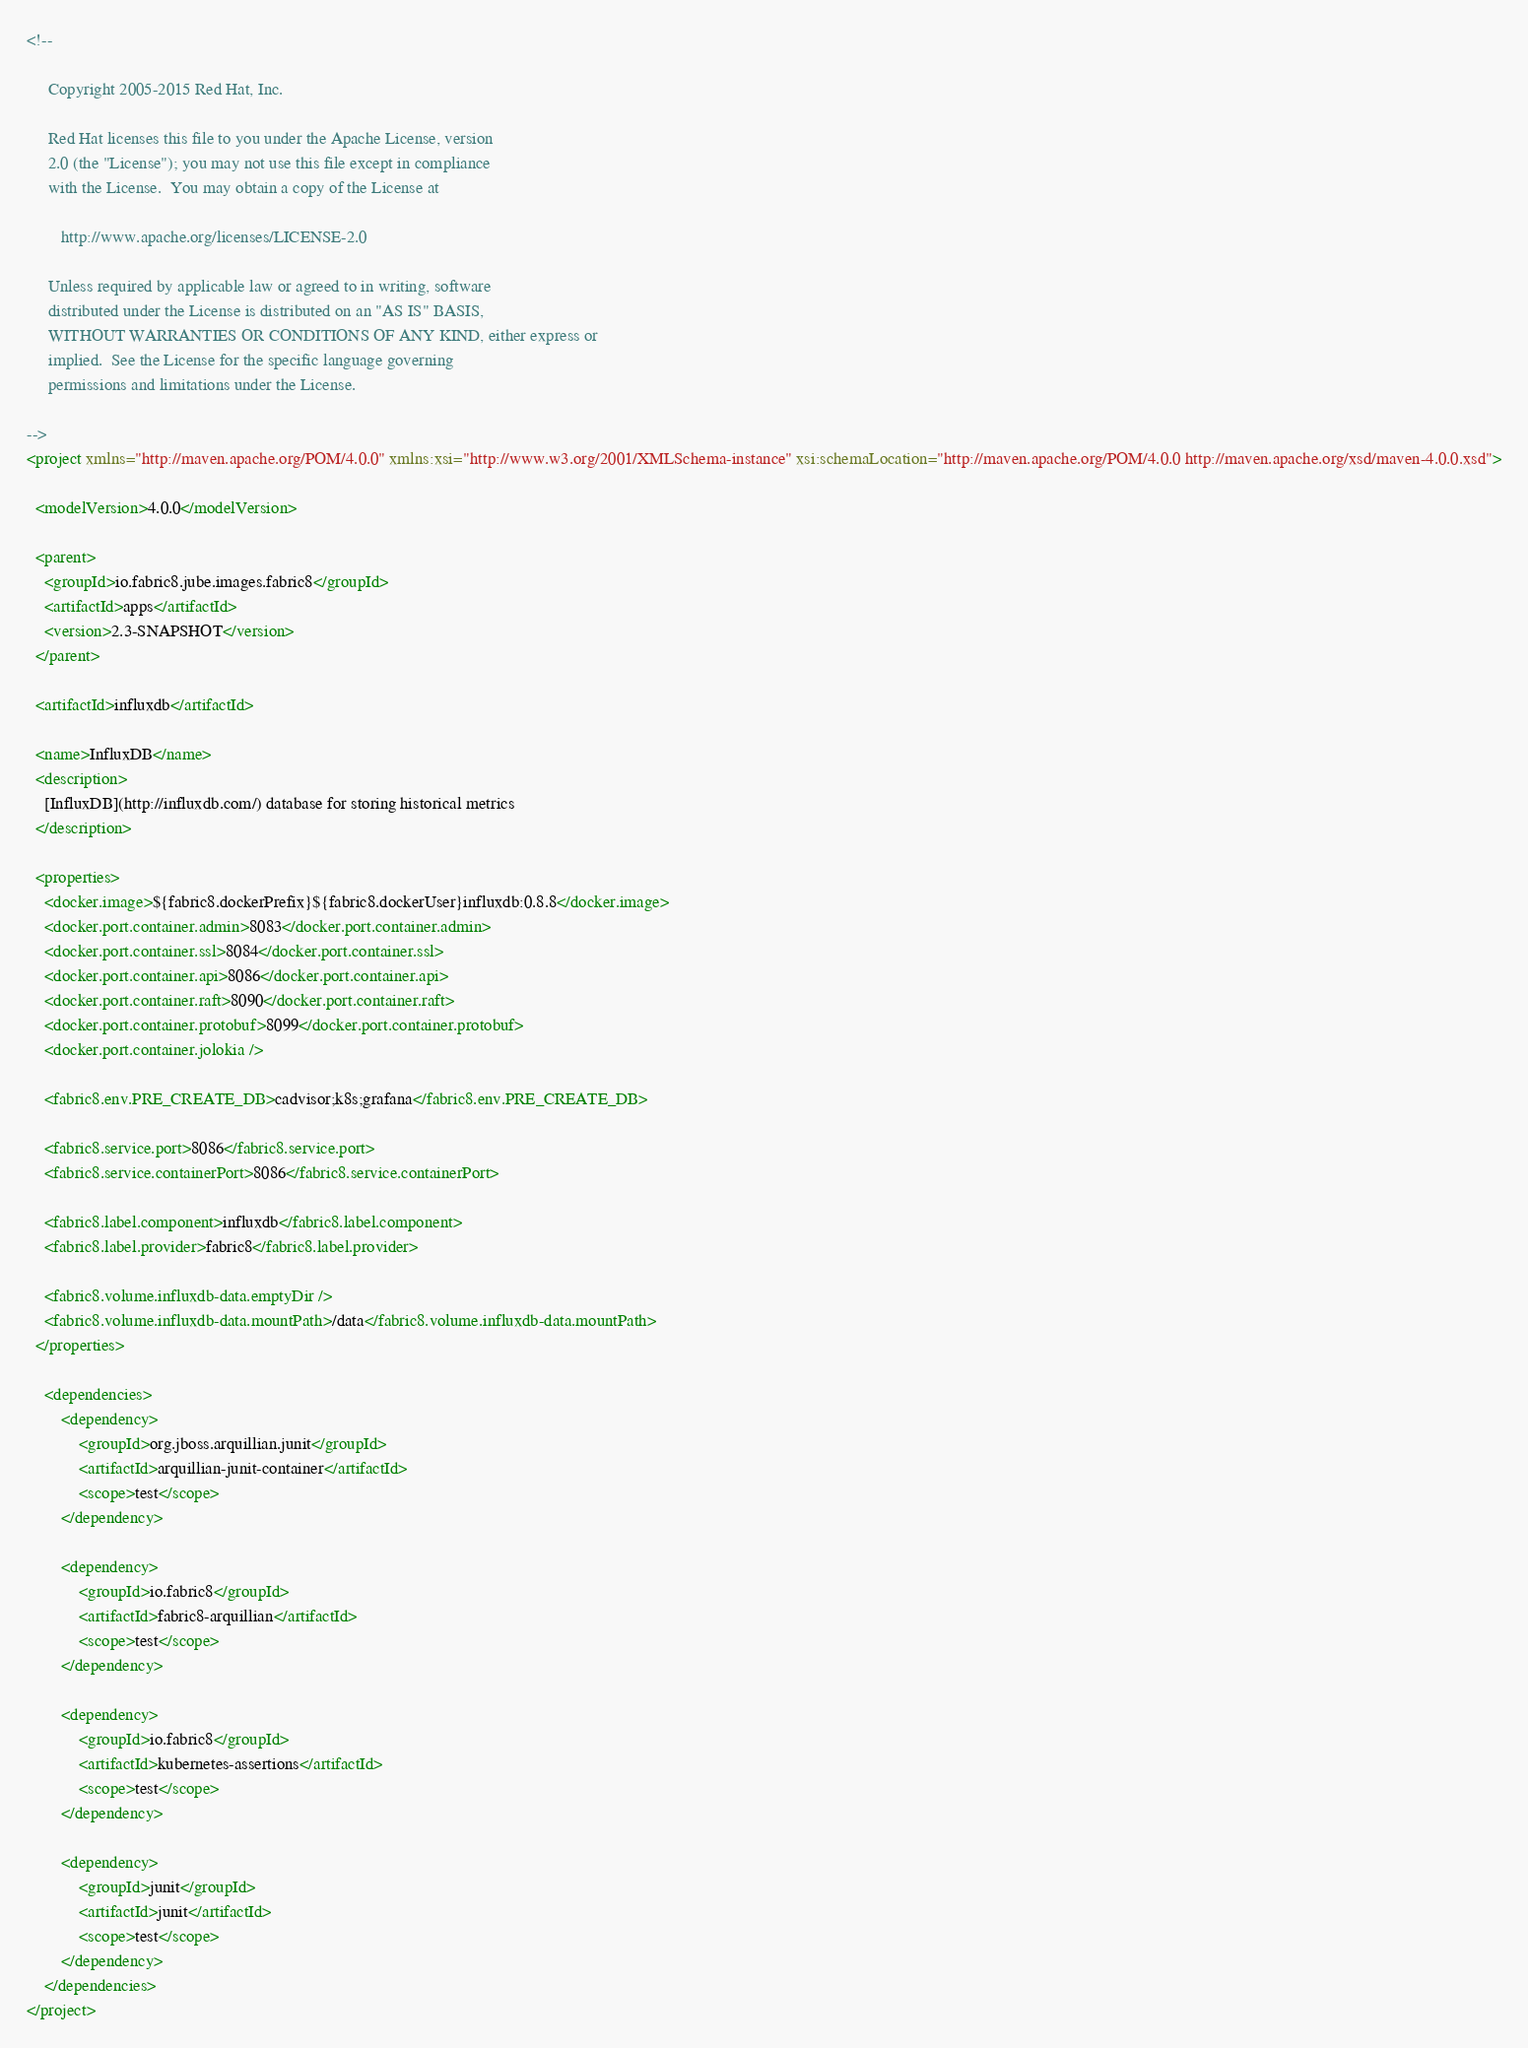<code> <loc_0><loc_0><loc_500><loc_500><_XML_><!--

     Copyright 2005-2015 Red Hat, Inc.

     Red Hat licenses this file to you under the Apache License, version
     2.0 (the "License"); you may not use this file except in compliance
     with the License.  You may obtain a copy of the License at

        http://www.apache.org/licenses/LICENSE-2.0

     Unless required by applicable law or agreed to in writing, software
     distributed under the License is distributed on an "AS IS" BASIS,
     WITHOUT WARRANTIES OR CONDITIONS OF ANY KIND, either express or
     implied.  See the License for the specific language governing
     permissions and limitations under the License.

-->
<project xmlns="http://maven.apache.org/POM/4.0.0" xmlns:xsi="http://www.w3.org/2001/XMLSchema-instance" xsi:schemaLocation="http://maven.apache.org/POM/4.0.0 http://maven.apache.org/xsd/maven-4.0.0.xsd">

  <modelVersion>4.0.0</modelVersion>

  <parent>
    <groupId>io.fabric8.jube.images.fabric8</groupId>
    <artifactId>apps</artifactId>
    <version>2.3-SNAPSHOT</version>
  </parent>

  <artifactId>influxdb</artifactId>

  <name>InfluxDB</name>
  <description>
    [InfluxDB](http://influxdb.com/) database for storing historical metrics
  </description>

  <properties>
    <docker.image>${fabric8.dockerPrefix}${fabric8.dockerUser}influxdb:0.8.8</docker.image>
    <docker.port.container.admin>8083</docker.port.container.admin>
    <docker.port.container.ssl>8084</docker.port.container.ssl>
    <docker.port.container.api>8086</docker.port.container.api>
    <docker.port.container.raft>8090</docker.port.container.raft>
    <docker.port.container.protobuf>8099</docker.port.container.protobuf>
    <docker.port.container.jolokia />

    <fabric8.env.PRE_CREATE_DB>cadvisor;k8s;grafana</fabric8.env.PRE_CREATE_DB>

    <fabric8.service.port>8086</fabric8.service.port>
    <fabric8.service.containerPort>8086</fabric8.service.containerPort>

    <fabric8.label.component>influxdb</fabric8.label.component>
    <fabric8.label.provider>fabric8</fabric8.label.provider>

    <fabric8.volume.influxdb-data.emptyDir />
    <fabric8.volume.influxdb-data.mountPath>/data</fabric8.volume.influxdb-data.mountPath>
  </properties>

    <dependencies>
        <dependency>
            <groupId>org.jboss.arquillian.junit</groupId>
            <artifactId>arquillian-junit-container</artifactId>
            <scope>test</scope>
        </dependency>

        <dependency>
            <groupId>io.fabric8</groupId>
            <artifactId>fabric8-arquillian</artifactId>
            <scope>test</scope>
        </dependency>

        <dependency>
            <groupId>io.fabric8</groupId>
            <artifactId>kubernetes-assertions</artifactId>
            <scope>test</scope>
        </dependency>

        <dependency>
            <groupId>junit</groupId>
            <artifactId>junit</artifactId>
            <scope>test</scope>
        </dependency>
    </dependencies>
</project>
</code> 